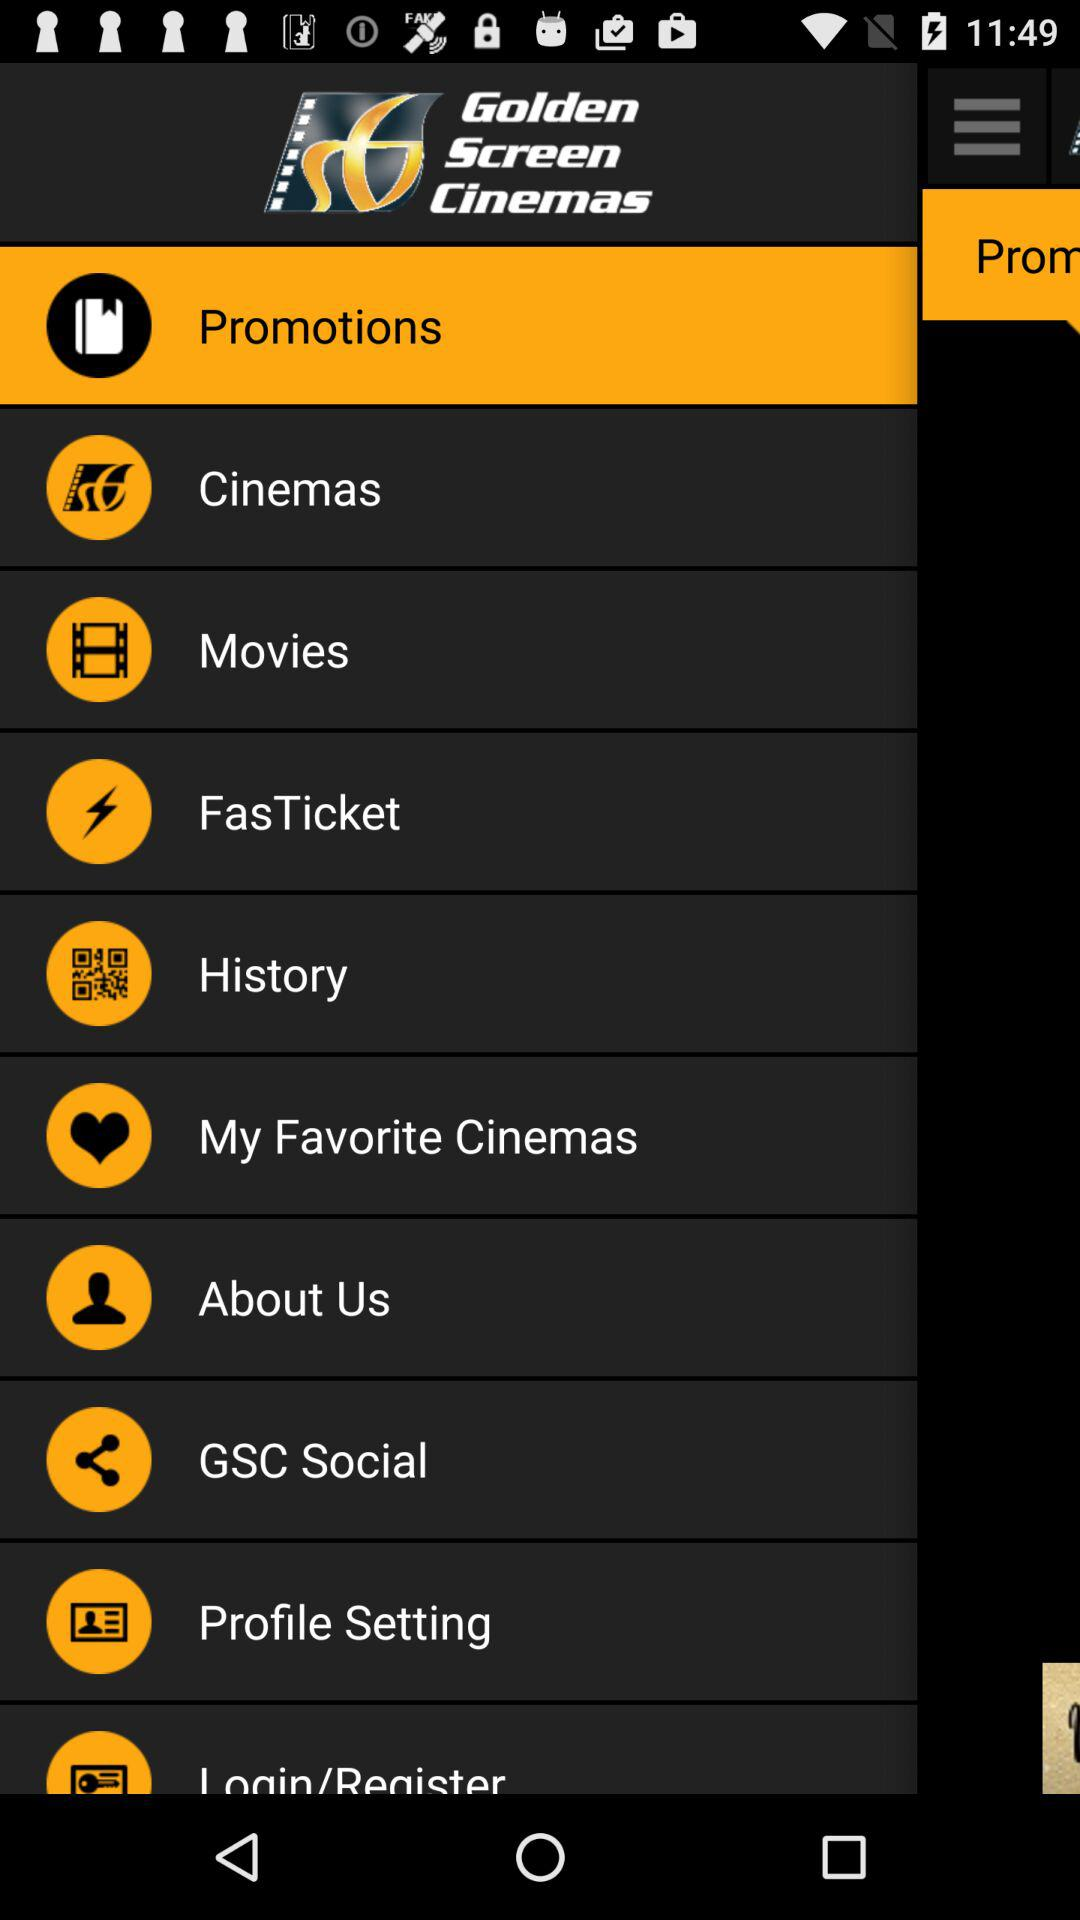What is the name of the application? The name of the application is "Golden Screen Cinemas". 